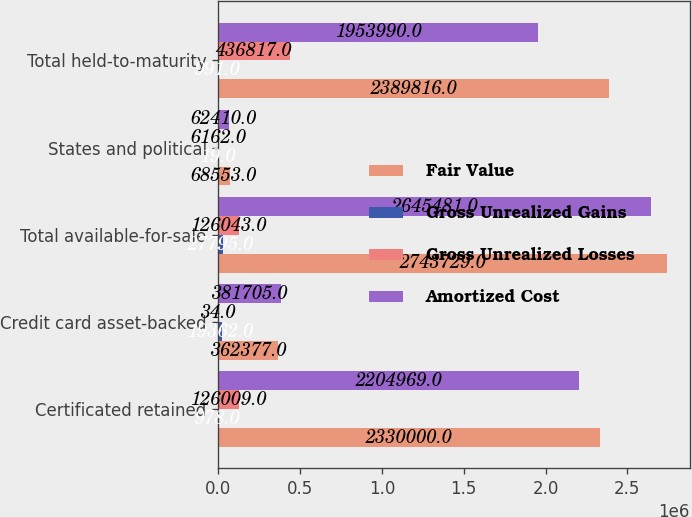<chart> <loc_0><loc_0><loc_500><loc_500><stacked_bar_chart><ecel><fcel>Certificated retained<fcel>Credit card asset-backed<fcel>Total available-for-sale<fcel>States and political<fcel>Total held-to-maturity<nl><fcel>Fair Value<fcel>2.33e+06<fcel>362377<fcel>2.74373e+06<fcel>68553<fcel>2.38982e+06<nl><fcel>Gross Unrealized Gains<fcel>978<fcel>19362<fcel>27795<fcel>19<fcel>991<nl><fcel>Gross Unrealized Losses<fcel>126009<fcel>34<fcel>126043<fcel>6162<fcel>436817<nl><fcel>Amortized Cost<fcel>2.20497e+06<fcel>381705<fcel>2.64548e+06<fcel>62410<fcel>1.95399e+06<nl></chart> 